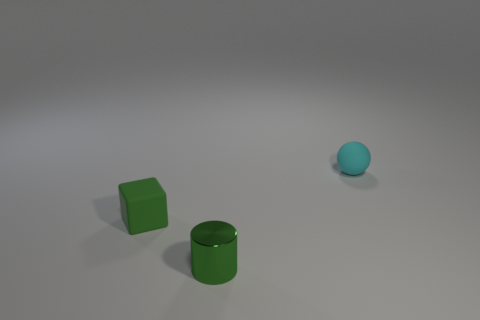Is the number of cubes that are in front of the shiny cylinder greater than the number of gray shiny cylinders?
Your response must be concise. No. There is a tiny rubber object to the right of the block; what is its color?
Make the answer very short. Cyan. Is the cyan object the same size as the green rubber cube?
Offer a very short reply. Yes. What is the size of the cyan thing?
Offer a terse response. Small. There is a object that is the same color as the cylinder; what shape is it?
Your answer should be compact. Cube. Is the number of metal objects greater than the number of yellow metallic cylinders?
Give a very brief answer. Yes. What is the color of the matte thing that is in front of the small matte thing that is on the right side of the small matte thing in front of the cyan matte ball?
Keep it short and to the point. Green. There is a cylinder that is the same size as the sphere; what color is it?
Your answer should be compact. Green. How many small gray metal spheres are there?
Ensure brevity in your answer.  0. Is the green object in front of the tiny matte block made of the same material as the tiny cube?
Offer a terse response. No. 